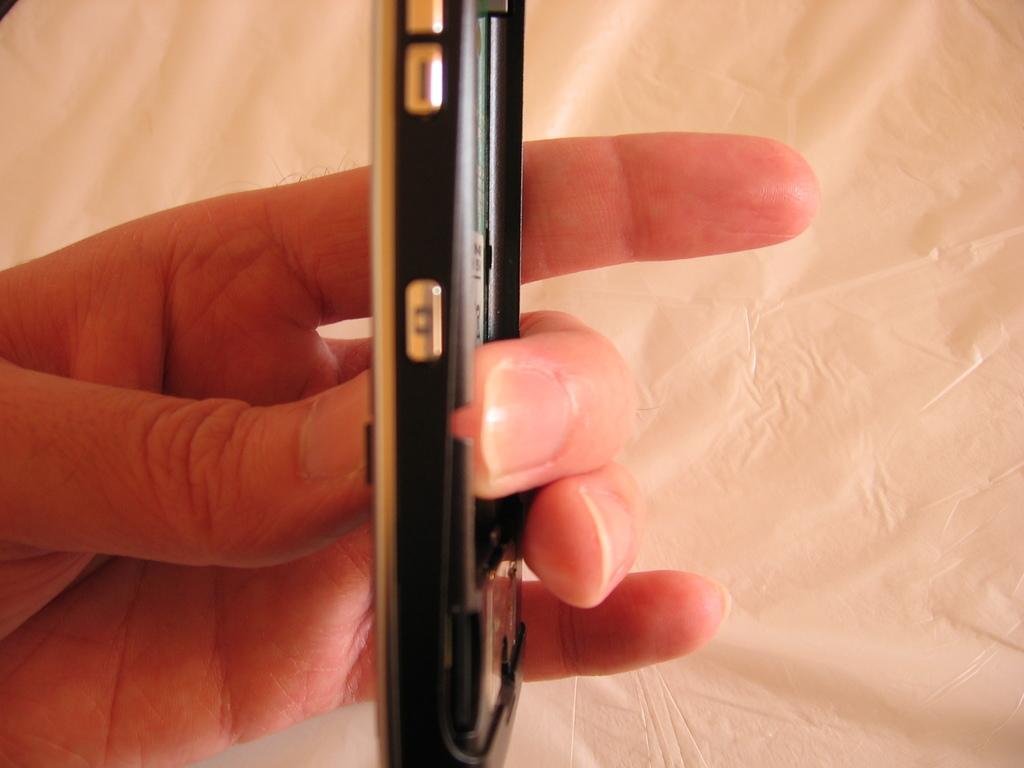Could you give a brief overview of what you see in this image? In this image there is a hand which is holding the mobile phone. At the bottom there is a white cloth. 